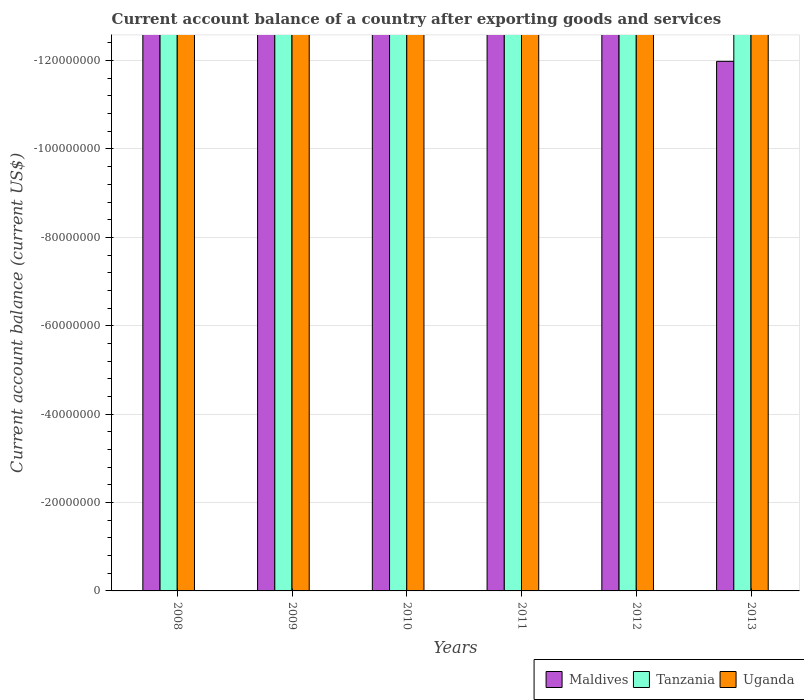Are the number of bars per tick equal to the number of legend labels?
Your answer should be compact. No. Are the number of bars on each tick of the X-axis equal?
Your answer should be compact. Yes. In how many cases, is the number of bars for a given year not equal to the number of legend labels?
Make the answer very short. 6. Across all years, what is the minimum account balance in Uganda?
Your response must be concise. 0. In how many years, is the account balance in Maldives greater than -76000000 US$?
Offer a terse response. 0. Is it the case that in every year, the sum of the account balance in Maldives and account balance in Tanzania is greater than the account balance in Uganda?
Offer a terse response. No. What is the difference between two consecutive major ticks on the Y-axis?
Give a very brief answer. 2.00e+07. Are the values on the major ticks of Y-axis written in scientific E-notation?
Make the answer very short. No. Does the graph contain any zero values?
Offer a very short reply. Yes. Where does the legend appear in the graph?
Keep it short and to the point. Bottom right. How are the legend labels stacked?
Provide a short and direct response. Horizontal. What is the title of the graph?
Give a very brief answer. Current account balance of a country after exporting goods and services. Does "Channel Islands" appear as one of the legend labels in the graph?
Your response must be concise. No. What is the label or title of the X-axis?
Offer a terse response. Years. What is the label or title of the Y-axis?
Offer a very short reply. Current account balance (current US$). What is the Current account balance (current US$) in Maldives in 2008?
Provide a succinct answer. 0. What is the Current account balance (current US$) in Maldives in 2009?
Your response must be concise. 0. What is the Current account balance (current US$) of Tanzania in 2009?
Ensure brevity in your answer.  0. What is the Current account balance (current US$) in Tanzania in 2010?
Your answer should be compact. 0. What is the Current account balance (current US$) of Uganda in 2010?
Provide a short and direct response. 0. What is the Current account balance (current US$) of Tanzania in 2011?
Your answer should be compact. 0. What is the Current account balance (current US$) of Tanzania in 2012?
Offer a very short reply. 0. What is the Current account balance (current US$) in Uganda in 2012?
Give a very brief answer. 0. What is the Current account balance (current US$) in Maldives in 2013?
Offer a very short reply. 0. What is the total Current account balance (current US$) in Tanzania in the graph?
Ensure brevity in your answer.  0. What is the total Current account balance (current US$) of Uganda in the graph?
Your answer should be compact. 0. What is the average Current account balance (current US$) of Tanzania per year?
Your answer should be very brief. 0. 